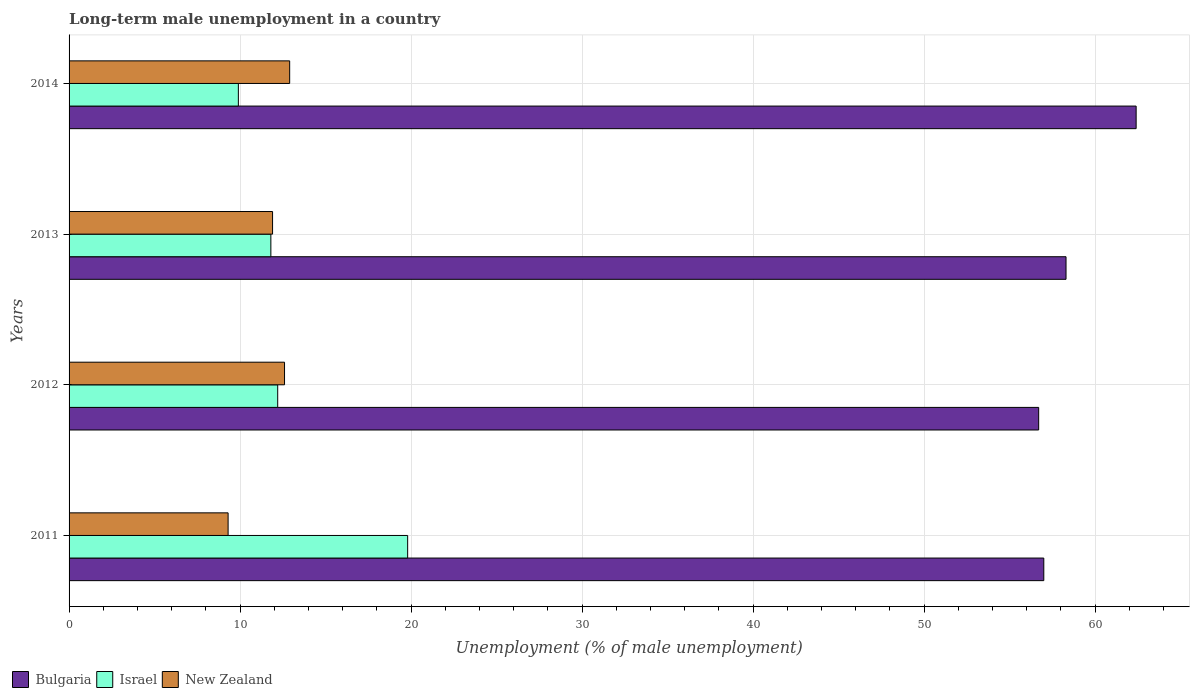How many different coloured bars are there?
Give a very brief answer. 3. What is the label of the 1st group of bars from the top?
Provide a short and direct response. 2014. What is the percentage of long-term unemployed male population in New Zealand in 2014?
Provide a succinct answer. 12.9. Across all years, what is the maximum percentage of long-term unemployed male population in New Zealand?
Your response must be concise. 12.9. Across all years, what is the minimum percentage of long-term unemployed male population in Bulgaria?
Your answer should be very brief. 56.7. In which year was the percentage of long-term unemployed male population in Israel minimum?
Your response must be concise. 2014. What is the total percentage of long-term unemployed male population in Bulgaria in the graph?
Your answer should be compact. 234.4. What is the difference between the percentage of long-term unemployed male population in Bulgaria in 2012 and that in 2014?
Provide a short and direct response. -5.7. What is the difference between the percentage of long-term unemployed male population in Bulgaria in 2013 and the percentage of long-term unemployed male population in New Zealand in 2012?
Offer a terse response. 45.7. What is the average percentage of long-term unemployed male population in New Zealand per year?
Provide a short and direct response. 11.67. In the year 2013, what is the difference between the percentage of long-term unemployed male population in Israel and percentage of long-term unemployed male population in New Zealand?
Ensure brevity in your answer.  -0.1. In how many years, is the percentage of long-term unemployed male population in New Zealand greater than 28 %?
Provide a short and direct response. 0. What is the ratio of the percentage of long-term unemployed male population in Bulgaria in 2011 to that in 2014?
Your response must be concise. 0.91. Is the percentage of long-term unemployed male population in New Zealand in 2011 less than that in 2012?
Your answer should be very brief. Yes. Is the difference between the percentage of long-term unemployed male population in Israel in 2011 and 2013 greater than the difference between the percentage of long-term unemployed male population in New Zealand in 2011 and 2013?
Offer a very short reply. Yes. What is the difference between the highest and the second highest percentage of long-term unemployed male population in Bulgaria?
Offer a very short reply. 4.1. What is the difference between the highest and the lowest percentage of long-term unemployed male population in New Zealand?
Provide a short and direct response. 3.6. Is the sum of the percentage of long-term unemployed male population in Bulgaria in 2012 and 2014 greater than the maximum percentage of long-term unemployed male population in Israel across all years?
Your answer should be compact. Yes. What does the 3rd bar from the bottom in 2011 represents?
Your answer should be very brief. New Zealand. Is it the case that in every year, the sum of the percentage of long-term unemployed male population in New Zealand and percentage of long-term unemployed male population in Bulgaria is greater than the percentage of long-term unemployed male population in Israel?
Your answer should be very brief. Yes. How many bars are there?
Your response must be concise. 12. Are all the bars in the graph horizontal?
Make the answer very short. Yes. How many years are there in the graph?
Offer a terse response. 4. Does the graph contain any zero values?
Offer a terse response. No. How are the legend labels stacked?
Ensure brevity in your answer.  Horizontal. What is the title of the graph?
Keep it short and to the point. Long-term male unemployment in a country. What is the label or title of the X-axis?
Your response must be concise. Unemployment (% of male unemployment). What is the label or title of the Y-axis?
Give a very brief answer. Years. What is the Unemployment (% of male unemployment) in Bulgaria in 2011?
Your answer should be very brief. 57. What is the Unemployment (% of male unemployment) of Israel in 2011?
Offer a very short reply. 19.8. What is the Unemployment (% of male unemployment) in New Zealand in 2011?
Ensure brevity in your answer.  9.3. What is the Unemployment (% of male unemployment) in Bulgaria in 2012?
Ensure brevity in your answer.  56.7. What is the Unemployment (% of male unemployment) in Israel in 2012?
Your answer should be compact. 12.2. What is the Unemployment (% of male unemployment) of New Zealand in 2012?
Give a very brief answer. 12.6. What is the Unemployment (% of male unemployment) in Bulgaria in 2013?
Your answer should be compact. 58.3. What is the Unemployment (% of male unemployment) of Israel in 2013?
Make the answer very short. 11.8. What is the Unemployment (% of male unemployment) in New Zealand in 2013?
Provide a short and direct response. 11.9. What is the Unemployment (% of male unemployment) of Bulgaria in 2014?
Your answer should be very brief. 62.4. What is the Unemployment (% of male unemployment) in Israel in 2014?
Provide a succinct answer. 9.9. What is the Unemployment (% of male unemployment) in New Zealand in 2014?
Offer a very short reply. 12.9. Across all years, what is the maximum Unemployment (% of male unemployment) in Bulgaria?
Make the answer very short. 62.4. Across all years, what is the maximum Unemployment (% of male unemployment) in Israel?
Keep it short and to the point. 19.8. Across all years, what is the maximum Unemployment (% of male unemployment) of New Zealand?
Ensure brevity in your answer.  12.9. Across all years, what is the minimum Unemployment (% of male unemployment) in Bulgaria?
Give a very brief answer. 56.7. Across all years, what is the minimum Unemployment (% of male unemployment) in Israel?
Offer a very short reply. 9.9. Across all years, what is the minimum Unemployment (% of male unemployment) in New Zealand?
Your answer should be very brief. 9.3. What is the total Unemployment (% of male unemployment) in Bulgaria in the graph?
Ensure brevity in your answer.  234.4. What is the total Unemployment (% of male unemployment) of Israel in the graph?
Keep it short and to the point. 53.7. What is the total Unemployment (% of male unemployment) of New Zealand in the graph?
Ensure brevity in your answer.  46.7. What is the difference between the Unemployment (% of male unemployment) in Israel in 2011 and that in 2013?
Your answer should be compact. 8. What is the difference between the Unemployment (% of male unemployment) in New Zealand in 2011 and that in 2013?
Offer a terse response. -2.6. What is the difference between the Unemployment (% of male unemployment) in New Zealand in 2012 and that in 2013?
Your answer should be compact. 0.7. What is the difference between the Unemployment (% of male unemployment) in New Zealand in 2012 and that in 2014?
Give a very brief answer. -0.3. What is the difference between the Unemployment (% of male unemployment) in Israel in 2013 and that in 2014?
Give a very brief answer. 1.9. What is the difference between the Unemployment (% of male unemployment) of New Zealand in 2013 and that in 2014?
Provide a short and direct response. -1. What is the difference between the Unemployment (% of male unemployment) in Bulgaria in 2011 and the Unemployment (% of male unemployment) in Israel in 2012?
Make the answer very short. 44.8. What is the difference between the Unemployment (% of male unemployment) of Bulgaria in 2011 and the Unemployment (% of male unemployment) of New Zealand in 2012?
Offer a very short reply. 44.4. What is the difference between the Unemployment (% of male unemployment) in Israel in 2011 and the Unemployment (% of male unemployment) in New Zealand in 2012?
Give a very brief answer. 7.2. What is the difference between the Unemployment (% of male unemployment) of Bulgaria in 2011 and the Unemployment (% of male unemployment) of Israel in 2013?
Offer a terse response. 45.2. What is the difference between the Unemployment (% of male unemployment) in Bulgaria in 2011 and the Unemployment (% of male unemployment) in New Zealand in 2013?
Your answer should be very brief. 45.1. What is the difference between the Unemployment (% of male unemployment) in Bulgaria in 2011 and the Unemployment (% of male unemployment) in Israel in 2014?
Your answer should be very brief. 47.1. What is the difference between the Unemployment (% of male unemployment) of Bulgaria in 2011 and the Unemployment (% of male unemployment) of New Zealand in 2014?
Offer a terse response. 44.1. What is the difference between the Unemployment (% of male unemployment) of Bulgaria in 2012 and the Unemployment (% of male unemployment) of Israel in 2013?
Ensure brevity in your answer.  44.9. What is the difference between the Unemployment (% of male unemployment) of Bulgaria in 2012 and the Unemployment (% of male unemployment) of New Zealand in 2013?
Your response must be concise. 44.8. What is the difference between the Unemployment (% of male unemployment) of Israel in 2012 and the Unemployment (% of male unemployment) of New Zealand in 2013?
Your answer should be very brief. 0.3. What is the difference between the Unemployment (% of male unemployment) of Bulgaria in 2012 and the Unemployment (% of male unemployment) of Israel in 2014?
Offer a terse response. 46.8. What is the difference between the Unemployment (% of male unemployment) of Bulgaria in 2012 and the Unemployment (% of male unemployment) of New Zealand in 2014?
Give a very brief answer. 43.8. What is the difference between the Unemployment (% of male unemployment) of Israel in 2012 and the Unemployment (% of male unemployment) of New Zealand in 2014?
Offer a very short reply. -0.7. What is the difference between the Unemployment (% of male unemployment) of Bulgaria in 2013 and the Unemployment (% of male unemployment) of Israel in 2014?
Keep it short and to the point. 48.4. What is the difference between the Unemployment (% of male unemployment) of Bulgaria in 2013 and the Unemployment (% of male unemployment) of New Zealand in 2014?
Your response must be concise. 45.4. What is the difference between the Unemployment (% of male unemployment) of Israel in 2013 and the Unemployment (% of male unemployment) of New Zealand in 2014?
Your answer should be very brief. -1.1. What is the average Unemployment (% of male unemployment) of Bulgaria per year?
Give a very brief answer. 58.6. What is the average Unemployment (% of male unemployment) in Israel per year?
Keep it short and to the point. 13.43. What is the average Unemployment (% of male unemployment) in New Zealand per year?
Your answer should be compact. 11.68. In the year 2011, what is the difference between the Unemployment (% of male unemployment) of Bulgaria and Unemployment (% of male unemployment) of Israel?
Keep it short and to the point. 37.2. In the year 2011, what is the difference between the Unemployment (% of male unemployment) in Bulgaria and Unemployment (% of male unemployment) in New Zealand?
Your answer should be very brief. 47.7. In the year 2011, what is the difference between the Unemployment (% of male unemployment) of Israel and Unemployment (% of male unemployment) of New Zealand?
Your answer should be compact. 10.5. In the year 2012, what is the difference between the Unemployment (% of male unemployment) in Bulgaria and Unemployment (% of male unemployment) in Israel?
Your response must be concise. 44.5. In the year 2012, what is the difference between the Unemployment (% of male unemployment) of Bulgaria and Unemployment (% of male unemployment) of New Zealand?
Keep it short and to the point. 44.1. In the year 2012, what is the difference between the Unemployment (% of male unemployment) in Israel and Unemployment (% of male unemployment) in New Zealand?
Provide a succinct answer. -0.4. In the year 2013, what is the difference between the Unemployment (% of male unemployment) of Bulgaria and Unemployment (% of male unemployment) of Israel?
Ensure brevity in your answer.  46.5. In the year 2013, what is the difference between the Unemployment (% of male unemployment) of Bulgaria and Unemployment (% of male unemployment) of New Zealand?
Make the answer very short. 46.4. In the year 2013, what is the difference between the Unemployment (% of male unemployment) in Israel and Unemployment (% of male unemployment) in New Zealand?
Provide a short and direct response. -0.1. In the year 2014, what is the difference between the Unemployment (% of male unemployment) in Bulgaria and Unemployment (% of male unemployment) in Israel?
Make the answer very short. 52.5. In the year 2014, what is the difference between the Unemployment (% of male unemployment) in Bulgaria and Unemployment (% of male unemployment) in New Zealand?
Provide a short and direct response. 49.5. What is the ratio of the Unemployment (% of male unemployment) in Israel in 2011 to that in 2012?
Offer a terse response. 1.62. What is the ratio of the Unemployment (% of male unemployment) in New Zealand in 2011 to that in 2012?
Your response must be concise. 0.74. What is the ratio of the Unemployment (% of male unemployment) of Bulgaria in 2011 to that in 2013?
Keep it short and to the point. 0.98. What is the ratio of the Unemployment (% of male unemployment) of Israel in 2011 to that in 2013?
Offer a very short reply. 1.68. What is the ratio of the Unemployment (% of male unemployment) in New Zealand in 2011 to that in 2013?
Give a very brief answer. 0.78. What is the ratio of the Unemployment (% of male unemployment) of Bulgaria in 2011 to that in 2014?
Your response must be concise. 0.91. What is the ratio of the Unemployment (% of male unemployment) in New Zealand in 2011 to that in 2014?
Keep it short and to the point. 0.72. What is the ratio of the Unemployment (% of male unemployment) of Bulgaria in 2012 to that in 2013?
Offer a terse response. 0.97. What is the ratio of the Unemployment (% of male unemployment) of Israel in 2012 to that in 2013?
Offer a very short reply. 1.03. What is the ratio of the Unemployment (% of male unemployment) in New Zealand in 2012 to that in 2013?
Provide a short and direct response. 1.06. What is the ratio of the Unemployment (% of male unemployment) of Bulgaria in 2012 to that in 2014?
Your answer should be compact. 0.91. What is the ratio of the Unemployment (% of male unemployment) of Israel in 2012 to that in 2014?
Ensure brevity in your answer.  1.23. What is the ratio of the Unemployment (% of male unemployment) in New Zealand in 2012 to that in 2014?
Offer a terse response. 0.98. What is the ratio of the Unemployment (% of male unemployment) in Bulgaria in 2013 to that in 2014?
Your answer should be compact. 0.93. What is the ratio of the Unemployment (% of male unemployment) in Israel in 2013 to that in 2014?
Make the answer very short. 1.19. What is the ratio of the Unemployment (% of male unemployment) in New Zealand in 2013 to that in 2014?
Give a very brief answer. 0.92. What is the difference between the highest and the lowest Unemployment (% of male unemployment) in Bulgaria?
Your answer should be compact. 5.7. What is the difference between the highest and the lowest Unemployment (% of male unemployment) of Israel?
Your answer should be compact. 9.9. 